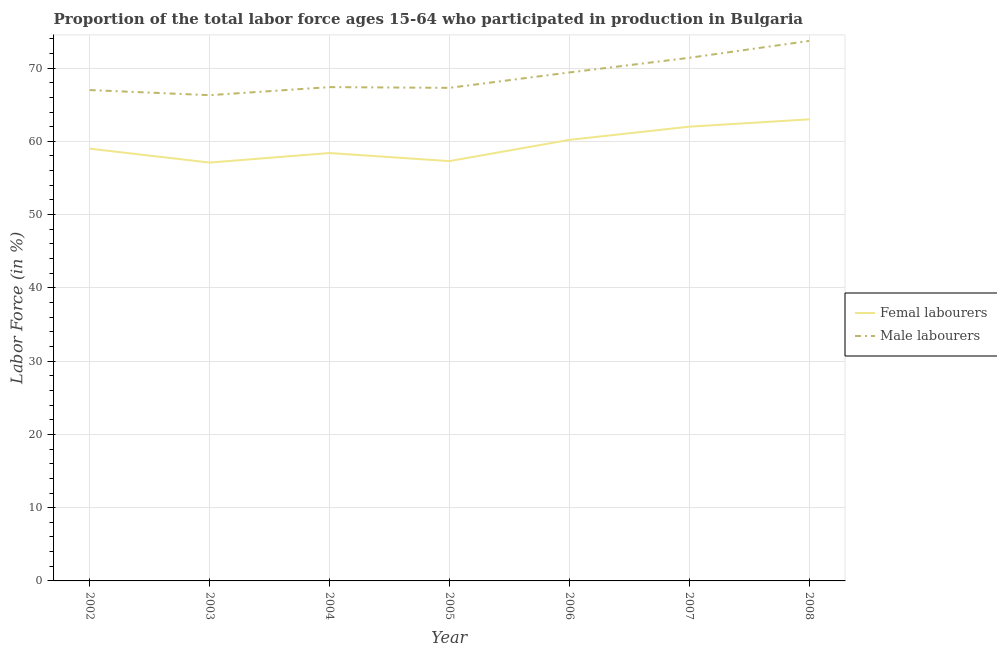How many different coloured lines are there?
Offer a very short reply. 2. Does the line corresponding to percentage of male labour force intersect with the line corresponding to percentage of female labor force?
Your answer should be very brief. No. Across all years, what is the minimum percentage of male labour force?
Provide a short and direct response. 66.3. In which year was the percentage of female labor force maximum?
Your answer should be compact. 2008. In which year was the percentage of male labour force minimum?
Provide a succinct answer. 2003. What is the total percentage of female labor force in the graph?
Provide a succinct answer. 417. What is the difference between the percentage of male labour force in 2002 and that in 2006?
Your answer should be very brief. -2.4. What is the difference between the percentage of male labour force in 2004 and the percentage of female labor force in 2003?
Provide a succinct answer. 10.3. What is the average percentage of female labor force per year?
Your answer should be compact. 59.57. In the year 2006, what is the difference between the percentage of female labor force and percentage of male labour force?
Make the answer very short. -9.2. In how many years, is the percentage of male labour force greater than 26 %?
Your answer should be compact. 7. What is the ratio of the percentage of male labour force in 2002 to that in 2007?
Make the answer very short. 0.94. What is the difference between the highest and the lowest percentage of male labour force?
Make the answer very short. 7.4. Does the percentage of female labor force monotonically increase over the years?
Provide a short and direct response. No. How many lines are there?
Keep it short and to the point. 2. How many years are there in the graph?
Keep it short and to the point. 7. Does the graph contain any zero values?
Give a very brief answer. No. How many legend labels are there?
Your answer should be very brief. 2. What is the title of the graph?
Your answer should be compact. Proportion of the total labor force ages 15-64 who participated in production in Bulgaria. Does "Forest" appear as one of the legend labels in the graph?
Keep it short and to the point. No. What is the label or title of the X-axis?
Keep it short and to the point. Year. What is the Labor Force (in %) of Femal labourers in 2002?
Provide a succinct answer. 59. What is the Labor Force (in %) of Male labourers in 2002?
Provide a succinct answer. 67. What is the Labor Force (in %) of Femal labourers in 2003?
Keep it short and to the point. 57.1. What is the Labor Force (in %) of Male labourers in 2003?
Make the answer very short. 66.3. What is the Labor Force (in %) of Femal labourers in 2004?
Your answer should be compact. 58.4. What is the Labor Force (in %) of Male labourers in 2004?
Your answer should be compact. 67.4. What is the Labor Force (in %) in Femal labourers in 2005?
Provide a succinct answer. 57.3. What is the Labor Force (in %) of Male labourers in 2005?
Ensure brevity in your answer.  67.3. What is the Labor Force (in %) in Femal labourers in 2006?
Provide a short and direct response. 60.2. What is the Labor Force (in %) in Male labourers in 2006?
Your response must be concise. 69.4. What is the Labor Force (in %) in Femal labourers in 2007?
Your answer should be compact. 62. What is the Labor Force (in %) in Male labourers in 2007?
Your answer should be compact. 71.4. What is the Labor Force (in %) in Femal labourers in 2008?
Provide a short and direct response. 63. What is the Labor Force (in %) in Male labourers in 2008?
Provide a succinct answer. 73.7. Across all years, what is the maximum Labor Force (in %) of Femal labourers?
Provide a short and direct response. 63. Across all years, what is the maximum Labor Force (in %) of Male labourers?
Provide a succinct answer. 73.7. Across all years, what is the minimum Labor Force (in %) in Femal labourers?
Offer a very short reply. 57.1. Across all years, what is the minimum Labor Force (in %) of Male labourers?
Give a very brief answer. 66.3. What is the total Labor Force (in %) in Femal labourers in the graph?
Ensure brevity in your answer.  417. What is the total Labor Force (in %) in Male labourers in the graph?
Ensure brevity in your answer.  482.5. What is the difference between the Labor Force (in %) in Femal labourers in 2002 and that in 2004?
Keep it short and to the point. 0.6. What is the difference between the Labor Force (in %) of Male labourers in 2002 and that in 2004?
Provide a short and direct response. -0.4. What is the difference between the Labor Force (in %) of Femal labourers in 2002 and that in 2005?
Your answer should be compact. 1.7. What is the difference between the Labor Force (in %) of Femal labourers in 2002 and that in 2006?
Offer a very short reply. -1.2. What is the difference between the Labor Force (in %) in Male labourers in 2002 and that in 2006?
Provide a short and direct response. -2.4. What is the difference between the Labor Force (in %) in Femal labourers in 2002 and that in 2007?
Make the answer very short. -3. What is the difference between the Labor Force (in %) in Femal labourers in 2002 and that in 2008?
Your response must be concise. -4. What is the difference between the Labor Force (in %) in Male labourers in 2003 and that in 2004?
Give a very brief answer. -1.1. What is the difference between the Labor Force (in %) of Male labourers in 2003 and that in 2005?
Make the answer very short. -1. What is the difference between the Labor Force (in %) in Femal labourers in 2003 and that in 2006?
Ensure brevity in your answer.  -3.1. What is the difference between the Labor Force (in %) of Femal labourers in 2003 and that in 2007?
Give a very brief answer. -4.9. What is the difference between the Labor Force (in %) of Male labourers in 2003 and that in 2007?
Offer a very short reply. -5.1. What is the difference between the Labor Force (in %) of Femal labourers in 2003 and that in 2008?
Keep it short and to the point. -5.9. What is the difference between the Labor Force (in %) in Male labourers in 2004 and that in 2005?
Make the answer very short. 0.1. What is the difference between the Labor Force (in %) of Femal labourers in 2004 and that in 2006?
Your answer should be compact. -1.8. What is the difference between the Labor Force (in %) of Femal labourers in 2004 and that in 2007?
Provide a short and direct response. -3.6. What is the difference between the Labor Force (in %) of Male labourers in 2004 and that in 2008?
Your answer should be compact. -6.3. What is the difference between the Labor Force (in %) of Femal labourers in 2005 and that in 2006?
Make the answer very short. -2.9. What is the difference between the Labor Force (in %) in Male labourers in 2005 and that in 2006?
Your answer should be very brief. -2.1. What is the difference between the Labor Force (in %) in Male labourers in 2005 and that in 2007?
Your answer should be compact. -4.1. What is the difference between the Labor Force (in %) of Male labourers in 2006 and that in 2007?
Provide a short and direct response. -2. What is the difference between the Labor Force (in %) in Femal labourers in 2002 and the Labor Force (in %) in Male labourers in 2003?
Your answer should be very brief. -7.3. What is the difference between the Labor Force (in %) in Femal labourers in 2002 and the Labor Force (in %) in Male labourers in 2008?
Your answer should be very brief. -14.7. What is the difference between the Labor Force (in %) in Femal labourers in 2003 and the Labor Force (in %) in Male labourers in 2005?
Provide a succinct answer. -10.2. What is the difference between the Labor Force (in %) in Femal labourers in 2003 and the Labor Force (in %) in Male labourers in 2007?
Provide a short and direct response. -14.3. What is the difference between the Labor Force (in %) of Femal labourers in 2003 and the Labor Force (in %) of Male labourers in 2008?
Offer a very short reply. -16.6. What is the difference between the Labor Force (in %) of Femal labourers in 2004 and the Labor Force (in %) of Male labourers in 2005?
Offer a terse response. -8.9. What is the difference between the Labor Force (in %) in Femal labourers in 2004 and the Labor Force (in %) in Male labourers in 2006?
Offer a terse response. -11. What is the difference between the Labor Force (in %) in Femal labourers in 2004 and the Labor Force (in %) in Male labourers in 2007?
Keep it short and to the point. -13. What is the difference between the Labor Force (in %) of Femal labourers in 2004 and the Labor Force (in %) of Male labourers in 2008?
Keep it short and to the point. -15.3. What is the difference between the Labor Force (in %) of Femal labourers in 2005 and the Labor Force (in %) of Male labourers in 2007?
Your answer should be very brief. -14.1. What is the difference between the Labor Force (in %) in Femal labourers in 2005 and the Labor Force (in %) in Male labourers in 2008?
Keep it short and to the point. -16.4. What is the difference between the Labor Force (in %) in Femal labourers in 2006 and the Labor Force (in %) in Male labourers in 2007?
Your answer should be compact. -11.2. What is the difference between the Labor Force (in %) in Femal labourers in 2006 and the Labor Force (in %) in Male labourers in 2008?
Offer a very short reply. -13.5. What is the average Labor Force (in %) of Femal labourers per year?
Offer a very short reply. 59.57. What is the average Labor Force (in %) of Male labourers per year?
Offer a terse response. 68.93. In the year 2003, what is the difference between the Labor Force (in %) in Femal labourers and Labor Force (in %) in Male labourers?
Ensure brevity in your answer.  -9.2. In the year 2004, what is the difference between the Labor Force (in %) in Femal labourers and Labor Force (in %) in Male labourers?
Make the answer very short. -9. In the year 2006, what is the difference between the Labor Force (in %) of Femal labourers and Labor Force (in %) of Male labourers?
Provide a succinct answer. -9.2. In the year 2007, what is the difference between the Labor Force (in %) in Femal labourers and Labor Force (in %) in Male labourers?
Provide a succinct answer. -9.4. In the year 2008, what is the difference between the Labor Force (in %) in Femal labourers and Labor Force (in %) in Male labourers?
Keep it short and to the point. -10.7. What is the ratio of the Labor Force (in %) in Male labourers in 2002 to that in 2003?
Make the answer very short. 1.01. What is the ratio of the Labor Force (in %) in Femal labourers in 2002 to that in 2004?
Your answer should be compact. 1.01. What is the ratio of the Labor Force (in %) in Male labourers in 2002 to that in 2004?
Your answer should be compact. 0.99. What is the ratio of the Labor Force (in %) of Femal labourers in 2002 to that in 2005?
Ensure brevity in your answer.  1.03. What is the ratio of the Labor Force (in %) of Male labourers in 2002 to that in 2005?
Provide a short and direct response. 1. What is the ratio of the Labor Force (in %) of Femal labourers in 2002 to that in 2006?
Offer a terse response. 0.98. What is the ratio of the Labor Force (in %) of Male labourers in 2002 to that in 2006?
Offer a terse response. 0.97. What is the ratio of the Labor Force (in %) in Femal labourers in 2002 to that in 2007?
Your response must be concise. 0.95. What is the ratio of the Labor Force (in %) of Male labourers in 2002 to that in 2007?
Offer a very short reply. 0.94. What is the ratio of the Labor Force (in %) of Femal labourers in 2002 to that in 2008?
Keep it short and to the point. 0.94. What is the ratio of the Labor Force (in %) of Male labourers in 2002 to that in 2008?
Keep it short and to the point. 0.91. What is the ratio of the Labor Force (in %) of Femal labourers in 2003 to that in 2004?
Give a very brief answer. 0.98. What is the ratio of the Labor Force (in %) in Male labourers in 2003 to that in 2004?
Offer a terse response. 0.98. What is the ratio of the Labor Force (in %) of Femal labourers in 2003 to that in 2005?
Provide a succinct answer. 1. What is the ratio of the Labor Force (in %) in Male labourers in 2003 to that in 2005?
Your response must be concise. 0.99. What is the ratio of the Labor Force (in %) of Femal labourers in 2003 to that in 2006?
Offer a terse response. 0.95. What is the ratio of the Labor Force (in %) of Male labourers in 2003 to that in 2006?
Keep it short and to the point. 0.96. What is the ratio of the Labor Force (in %) of Femal labourers in 2003 to that in 2007?
Give a very brief answer. 0.92. What is the ratio of the Labor Force (in %) of Femal labourers in 2003 to that in 2008?
Your response must be concise. 0.91. What is the ratio of the Labor Force (in %) of Male labourers in 2003 to that in 2008?
Make the answer very short. 0.9. What is the ratio of the Labor Force (in %) in Femal labourers in 2004 to that in 2005?
Your response must be concise. 1.02. What is the ratio of the Labor Force (in %) in Male labourers in 2004 to that in 2005?
Your answer should be compact. 1. What is the ratio of the Labor Force (in %) of Femal labourers in 2004 to that in 2006?
Your answer should be very brief. 0.97. What is the ratio of the Labor Force (in %) of Male labourers in 2004 to that in 2006?
Provide a succinct answer. 0.97. What is the ratio of the Labor Force (in %) of Femal labourers in 2004 to that in 2007?
Your response must be concise. 0.94. What is the ratio of the Labor Force (in %) of Male labourers in 2004 to that in 2007?
Offer a very short reply. 0.94. What is the ratio of the Labor Force (in %) in Femal labourers in 2004 to that in 2008?
Offer a very short reply. 0.93. What is the ratio of the Labor Force (in %) in Male labourers in 2004 to that in 2008?
Ensure brevity in your answer.  0.91. What is the ratio of the Labor Force (in %) in Femal labourers in 2005 to that in 2006?
Offer a terse response. 0.95. What is the ratio of the Labor Force (in %) in Male labourers in 2005 to that in 2006?
Provide a short and direct response. 0.97. What is the ratio of the Labor Force (in %) in Femal labourers in 2005 to that in 2007?
Offer a terse response. 0.92. What is the ratio of the Labor Force (in %) of Male labourers in 2005 to that in 2007?
Provide a short and direct response. 0.94. What is the ratio of the Labor Force (in %) of Femal labourers in 2005 to that in 2008?
Offer a terse response. 0.91. What is the ratio of the Labor Force (in %) of Male labourers in 2005 to that in 2008?
Your answer should be very brief. 0.91. What is the ratio of the Labor Force (in %) in Femal labourers in 2006 to that in 2007?
Make the answer very short. 0.97. What is the ratio of the Labor Force (in %) in Femal labourers in 2006 to that in 2008?
Ensure brevity in your answer.  0.96. What is the ratio of the Labor Force (in %) in Male labourers in 2006 to that in 2008?
Offer a very short reply. 0.94. What is the ratio of the Labor Force (in %) in Femal labourers in 2007 to that in 2008?
Ensure brevity in your answer.  0.98. What is the ratio of the Labor Force (in %) of Male labourers in 2007 to that in 2008?
Your answer should be very brief. 0.97. What is the difference between the highest and the second highest Labor Force (in %) of Femal labourers?
Provide a short and direct response. 1. What is the difference between the highest and the lowest Labor Force (in %) of Femal labourers?
Ensure brevity in your answer.  5.9. 